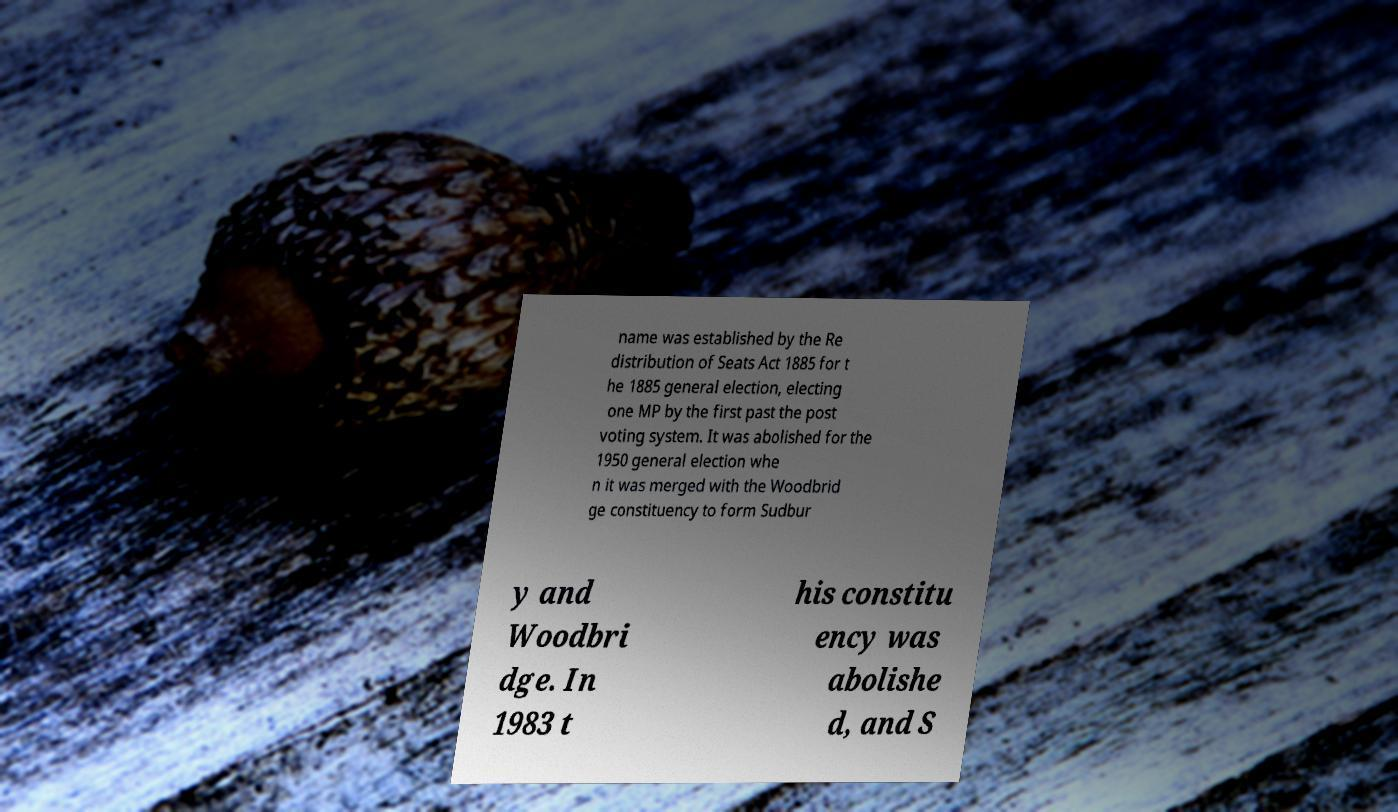Please read and relay the text visible in this image. What does it say? name was established by the Re distribution of Seats Act 1885 for t he 1885 general election, electing one MP by the first past the post voting system. It was abolished for the 1950 general election whe n it was merged with the Woodbrid ge constituency to form Sudbur y and Woodbri dge. In 1983 t his constitu ency was abolishe d, and S 